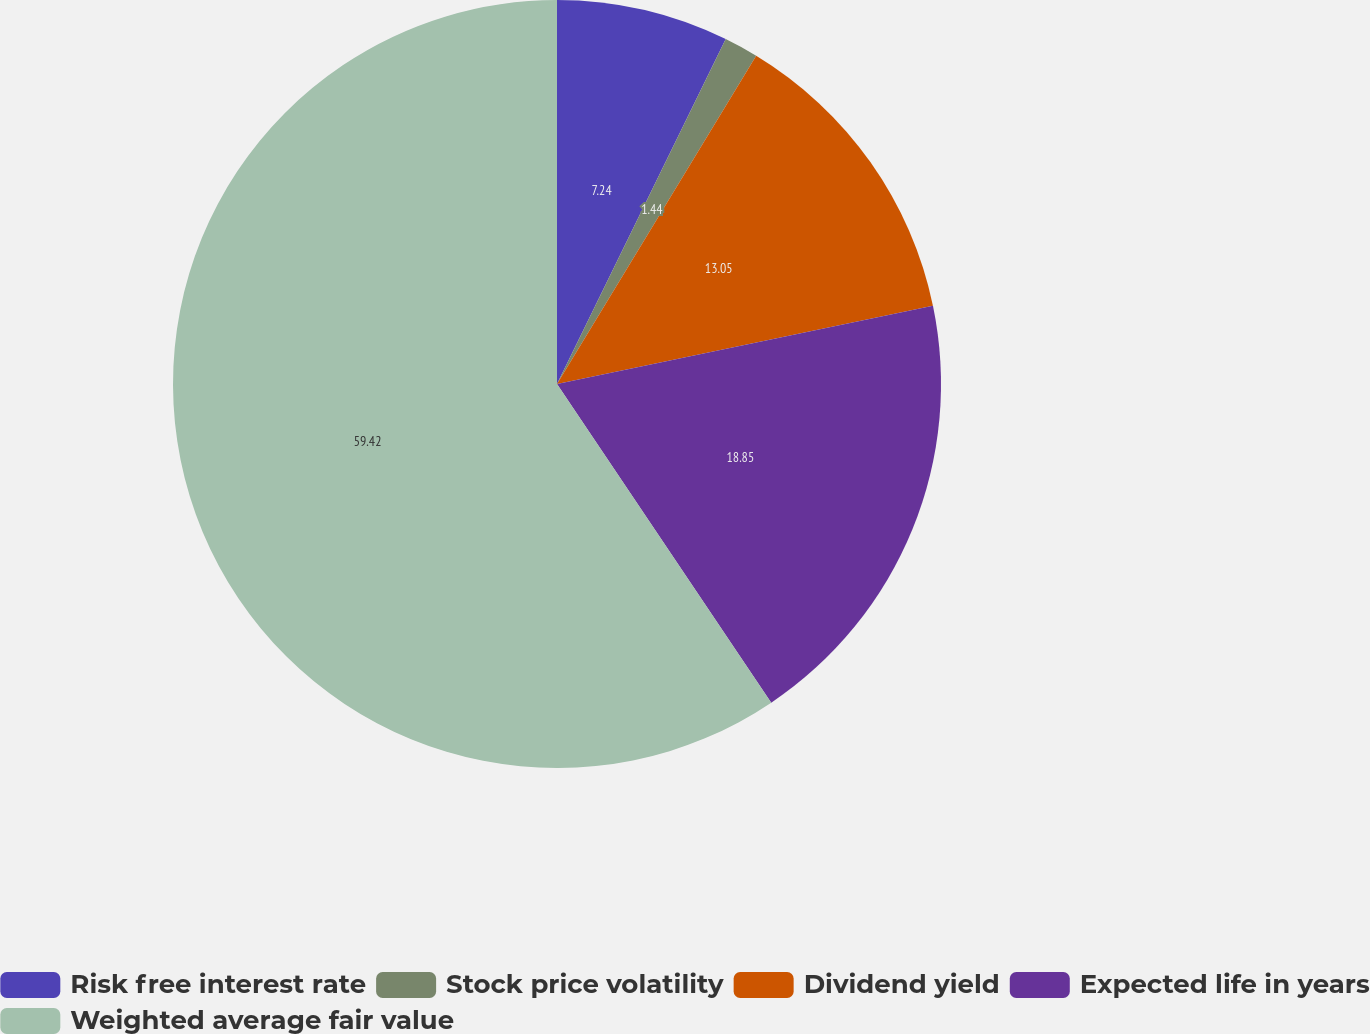Convert chart. <chart><loc_0><loc_0><loc_500><loc_500><pie_chart><fcel>Risk free interest rate<fcel>Stock price volatility<fcel>Dividend yield<fcel>Expected life in years<fcel>Weighted average fair value<nl><fcel>7.24%<fcel>1.44%<fcel>13.05%<fcel>18.85%<fcel>59.42%<nl></chart> 